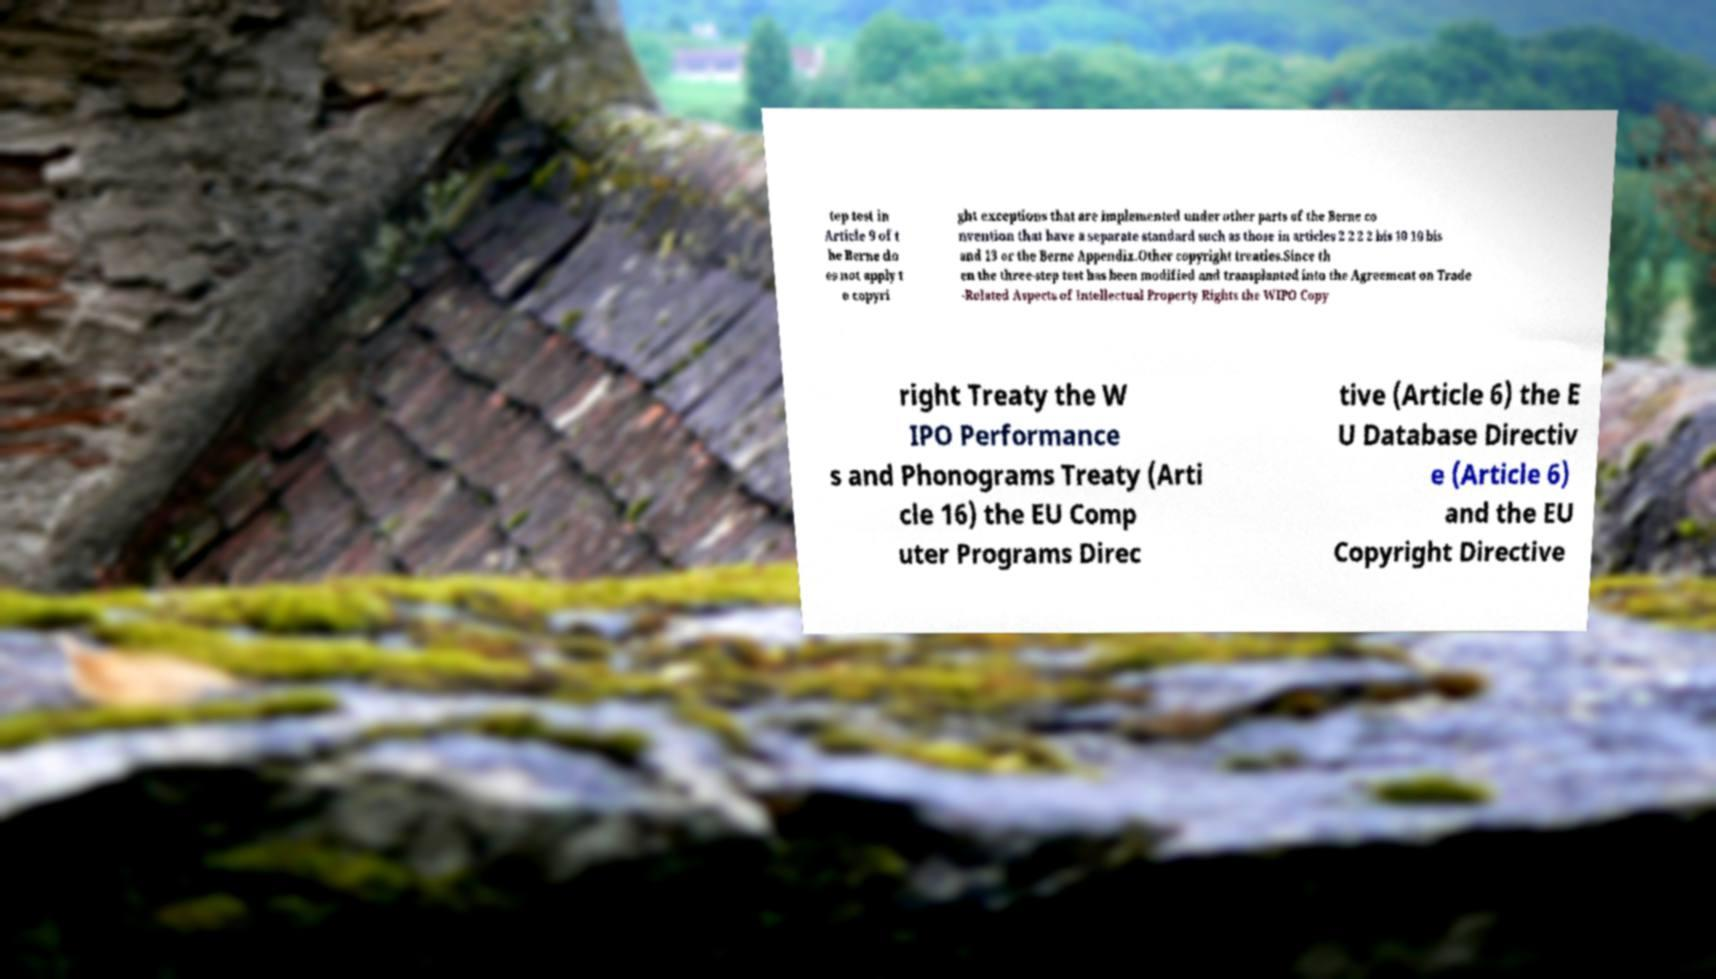Could you extract and type out the text from this image? tep test in Article 9 of t he Berne do es not apply t o copyri ght exceptions that are implemented under other parts of the Berne co nvention that have a separate standard such as those in articles 2 2 2 2 bis 10 10 bis and 13 or the Berne Appendix.Other copyright treaties.Since th en the three-step test has been modified and transplanted into the Agreement on Trade -Related Aspects of Intellectual Property Rights the WIPO Copy right Treaty the W IPO Performance s and Phonograms Treaty (Arti cle 16) the EU Comp uter Programs Direc tive (Article 6) the E U Database Directiv e (Article 6) and the EU Copyright Directive 